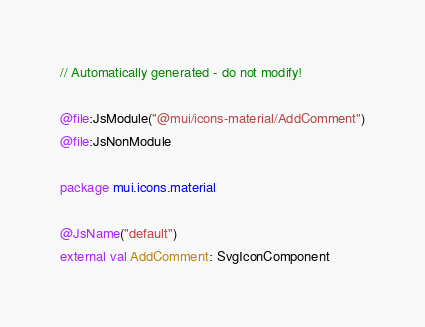Convert code to text. <code><loc_0><loc_0><loc_500><loc_500><_Kotlin_>// Automatically generated - do not modify!

@file:JsModule("@mui/icons-material/AddComment")
@file:JsNonModule

package mui.icons.material

@JsName("default")
external val AddComment: SvgIconComponent
</code> 